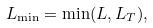Convert formula to latex. <formula><loc_0><loc_0><loc_500><loc_500>L _ { \min } = \min ( L , L _ { T } ) ,</formula> 